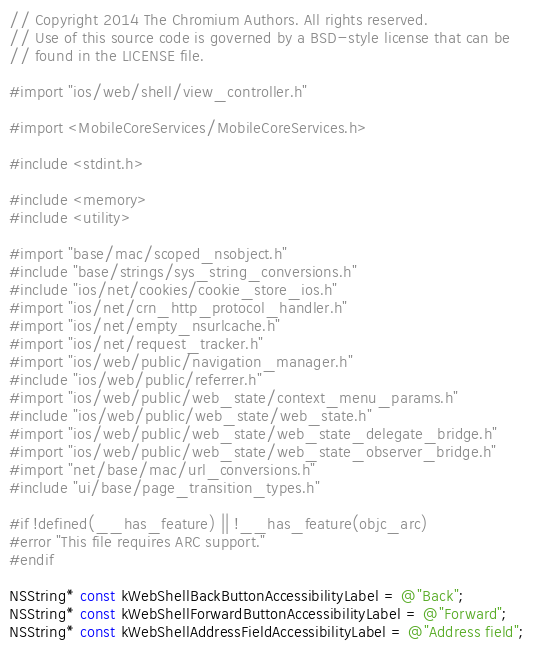<code> <loc_0><loc_0><loc_500><loc_500><_ObjectiveC_>// Copyright 2014 The Chromium Authors. All rights reserved.
// Use of this source code is governed by a BSD-style license that can be
// found in the LICENSE file.

#import "ios/web/shell/view_controller.h"

#import <MobileCoreServices/MobileCoreServices.h>

#include <stdint.h>

#include <memory>
#include <utility>

#import "base/mac/scoped_nsobject.h"
#include "base/strings/sys_string_conversions.h"
#include "ios/net/cookies/cookie_store_ios.h"
#import "ios/net/crn_http_protocol_handler.h"
#import "ios/net/empty_nsurlcache.h"
#import "ios/net/request_tracker.h"
#import "ios/web/public/navigation_manager.h"
#include "ios/web/public/referrer.h"
#import "ios/web/public/web_state/context_menu_params.h"
#include "ios/web/public/web_state/web_state.h"
#import "ios/web/public/web_state/web_state_delegate_bridge.h"
#import "ios/web/public/web_state/web_state_observer_bridge.h"
#import "net/base/mac/url_conversions.h"
#include "ui/base/page_transition_types.h"

#if !defined(__has_feature) || !__has_feature(objc_arc)
#error "This file requires ARC support."
#endif

NSString* const kWebShellBackButtonAccessibilityLabel = @"Back";
NSString* const kWebShellForwardButtonAccessibilityLabel = @"Forward";
NSString* const kWebShellAddressFieldAccessibilityLabel = @"Address field";
</code> 